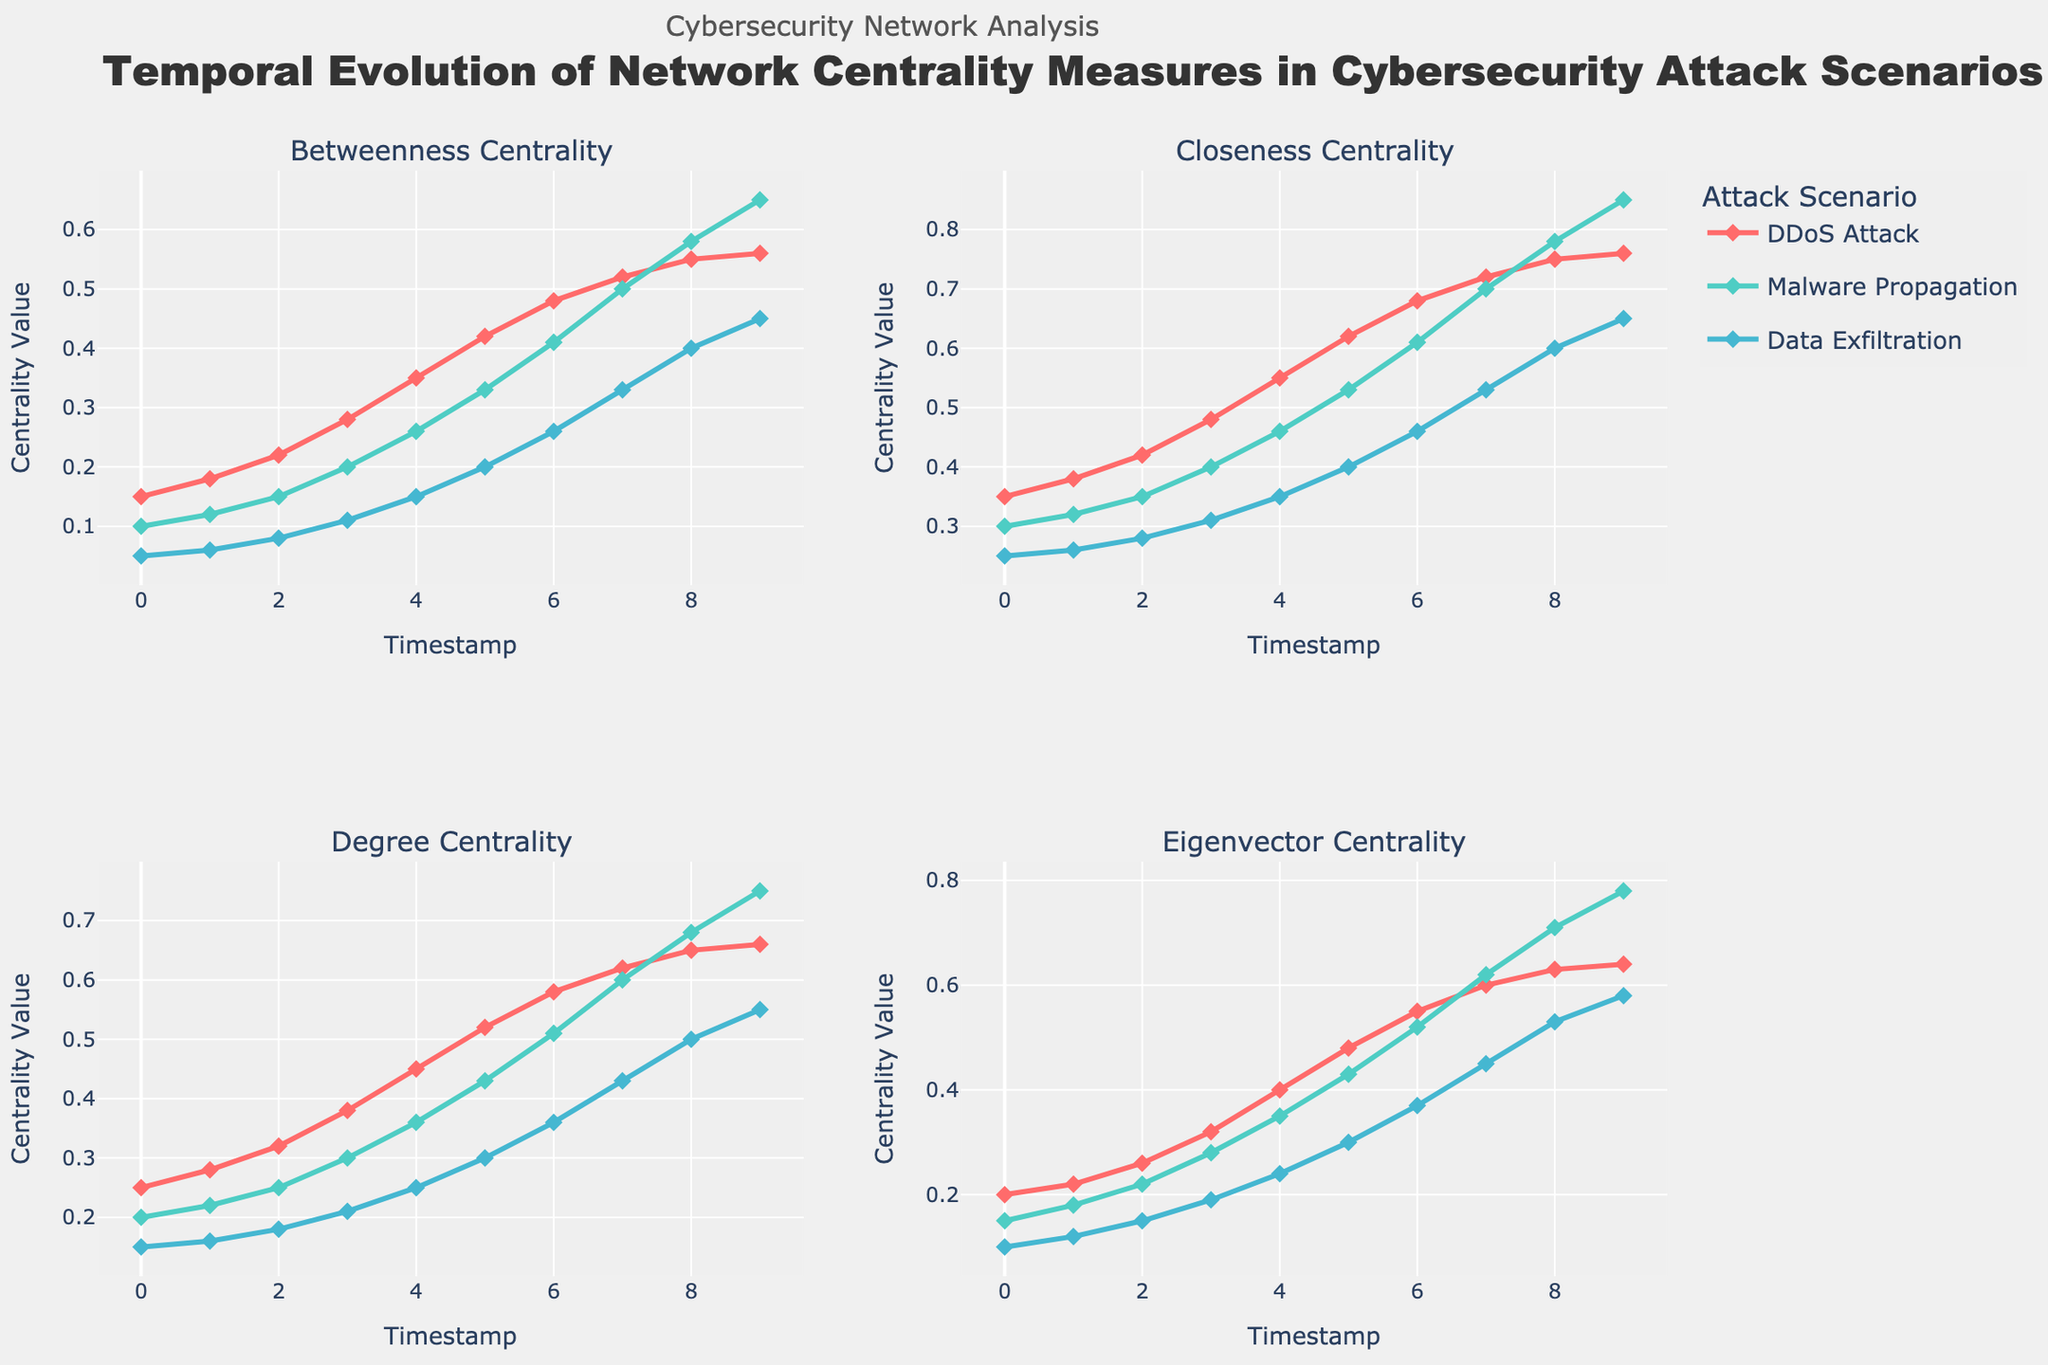What is the trend of betweenness centrality in the DDoS Attack scenario over time? Observe the line representing the DDoS Attack scenario in the Betweenness Centrality subplot. The betweenness centrality increases steadily from 0.15 at timestamp 0 to 0.56 at timestamp 9.
Answer: Increases steadily How does the closeness centrality of Data Exfiltration at timestamp 9 compare to that of Malware Propagation? Find the closeness centrality values for Data Exfiltration (0.65) and Malware Propagation (0.85) at timestamp 9 in the Closeness Centrality subplot. Compare these two values.
Answer: Lower for Data Exfiltration What is the difference in eigenvector centrality between timestamps 8 and 4 for the Malware Propagation scenario? Locate the eigenvector centrality values for Malware Propagation at timestamps 8 (0.71) and 4 (0.35) in the Eigenvector Centrality subplot. Subtract the value at timestamp 4 from the value at timestamp 8: 0.71 - 0.35.
Answer: 0.36 Which attack scenario has the highest degree centrality at timestamp 7? Identify the lines for each attack scenario in the Degree Centrality subplot at timestamp 7. Compare the values: DDoS Attack (0.62), Malware Propagation (0.60), Data Exfiltration (0.43).
Answer: DDoS Attack What is the average betweenness centrality for Data Exfiltration from timestamp 0 to 9? Sum the betweenness centrality values for Data Exfiltration (0.05, 0.06, 0.08, 0.11, 0.15, 0.20, 0.26, 0.33, 0.40, 0.45) and divide by 10: (0.05 + 0.06 + 0.08 + 0.11 + 0.15 + 0.20 + 0.26 + 0.33 + 0.40 + 0.45)/10.
Answer: 0.23 How do the trends of degree centrality in DDoS Attack and Malware Propagation compare over time? Both lines in the Degree Centrality subplot show steady increases over time. The degree centrality for DDoS Attack starts at 0.25 and ends at 0.66, while for Malware Propagation it starts at 0.20 and ends at 0.75. Both lines have a similar upward trend.
Answer: Similar upward trends Between timestamps 0 and 5, which scenario showed the greatest increase in closeness centrality? Calculate the difference in closeness centrality from timestamp 0 to 5 for each scenario in the Closeness Centrality subplot: DDoS Attack (0.62 - 0.35 = 0.27), Malware Propagation (0.53 - 0.30 = 0.23), Data Exfiltration (0.40 - 0.25 = 0.15).
Answer: DDoS Attack 